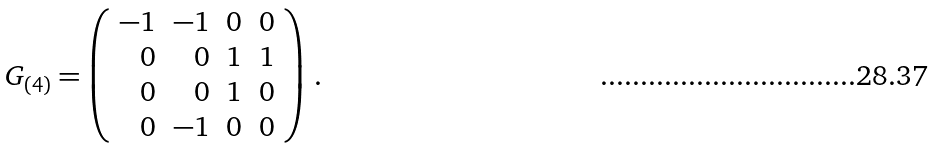Convert formula to latex. <formula><loc_0><loc_0><loc_500><loc_500>G _ { ( 4 ) } = \left ( \begin{array} { r r r r } - 1 & - 1 & 0 & 0 \\ 0 & 0 & 1 & 1 \\ 0 & 0 & 1 & 0 \\ 0 & - 1 & 0 & 0 \\ \end{array} \right ) \, .</formula> 